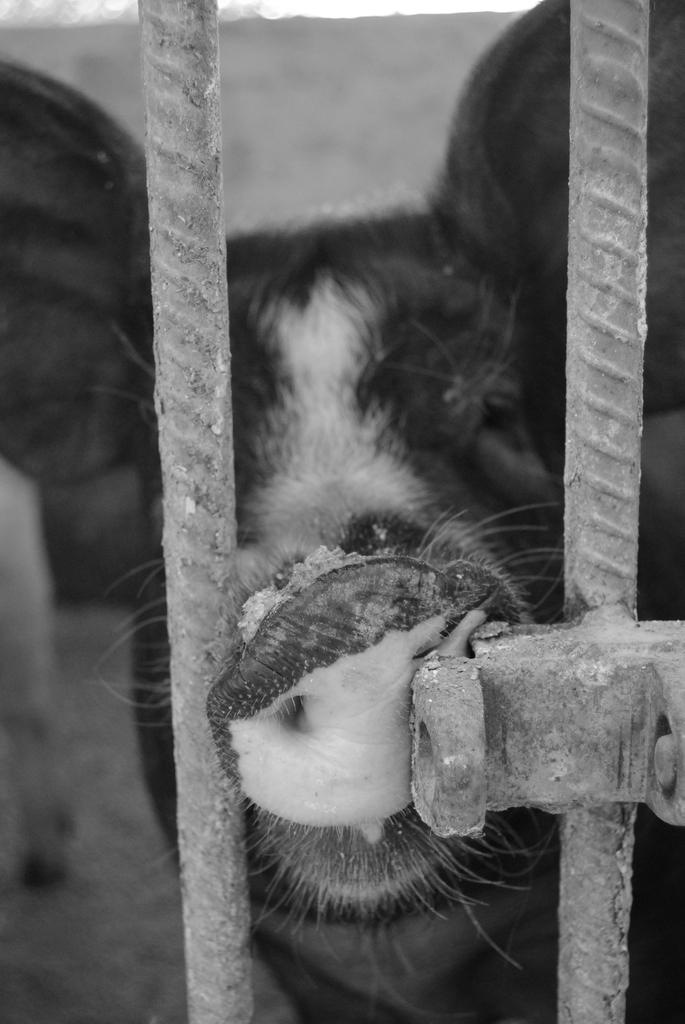What objects can be seen in the front of the image? There are metal rods in the front of the image. What is the main subject in the center of the image? There is an animal in the center of the image. What can be seen in the background of the image? There is a wall in the background of the image. What type of grape is being used as a prop by the animal in the image? There is no grape present in the image, and the animal is not using any props. 